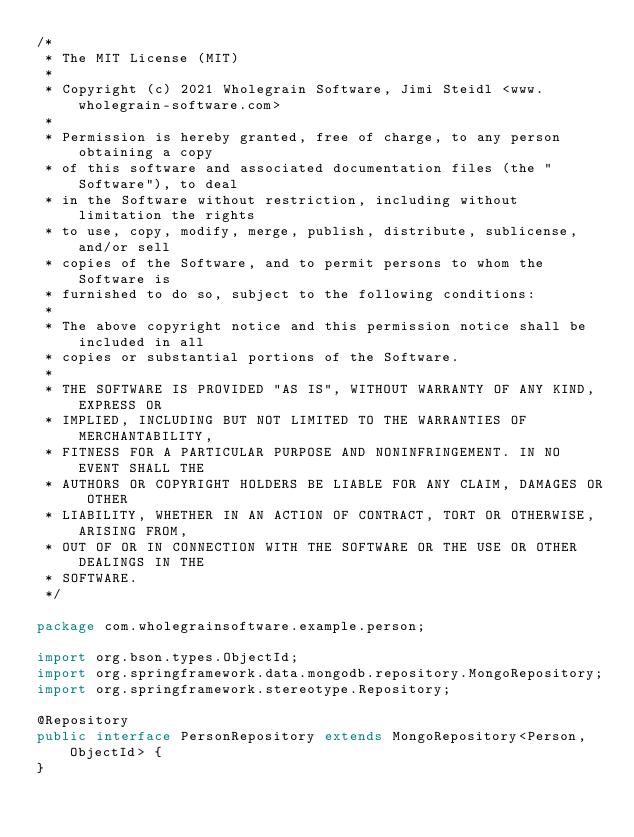<code> <loc_0><loc_0><loc_500><loc_500><_Java_>/*
 * The MIT License (MIT)
 *
 * Copyright (c) 2021 Wholegrain Software, Jimi Steidl <www.wholegrain-software.com>
 *
 * Permission is hereby granted, free of charge, to any person obtaining a copy
 * of this software and associated documentation files (the "Software"), to deal
 * in the Software without restriction, including without limitation the rights
 * to use, copy, modify, merge, publish, distribute, sublicense, and/or sell
 * copies of the Software, and to permit persons to whom the Software is
 * furnished to do so, subject to the following conditions:
 *
 * The above copyright notice and this permission notice shall be included in all
 * copies or substantial portions of the Software.
 *
 * THE SOFTWARE IS PROVIDED "AS IS", WITHOUT WARRANTY OF ANY KIND, EXPRESS OR
 * IMPLIED, INCLUDING BUT NOT LIMITED TO THE WARRANTIES OF MERCHANTABILITY,
 * FITNESS FOR A PARTICULAR PURPOSE AND NONINFRINGEMENT. IN NO EVENT SHALL THE
 * AUTHORS OR COPYRIGHT HOLDERS BE LIABLE FOR ANY CLAIM, DAMAGES OR OTHER
 * LIABILITY, WHETHER IN AN ACTION OF CONTRACT, TORT OR OTHERWISE, ARISING FROM,
 * OUT OF OR IN CONNECTION WITH THE SOFTWARE OR THE USE OR OTHER DEALINGS IN THE
 * SOFTWARE.
 */

package com.wholegrainsoftware.example.person;

import org.bson.types.ObjectId;
import org.springframework.data.mongodb.repository.MongoRepository;
import org.springframework.stereotype.Repository;

@Repository
public interface PersonRepository extends MongoRepository<Person, ObjectId> {
}
</code> 